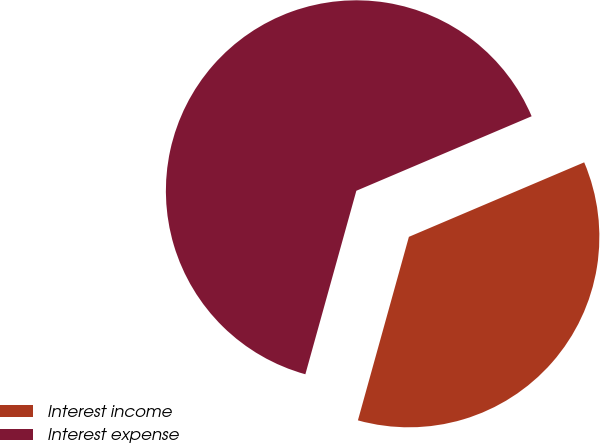<chart> <loc_0><loc_0><loc_500><loc_500><pie_chart><fcel>Interest income<fcel>Interest expense<nl><fcel>35.71%<fcel>64.29%<nl></chart> 